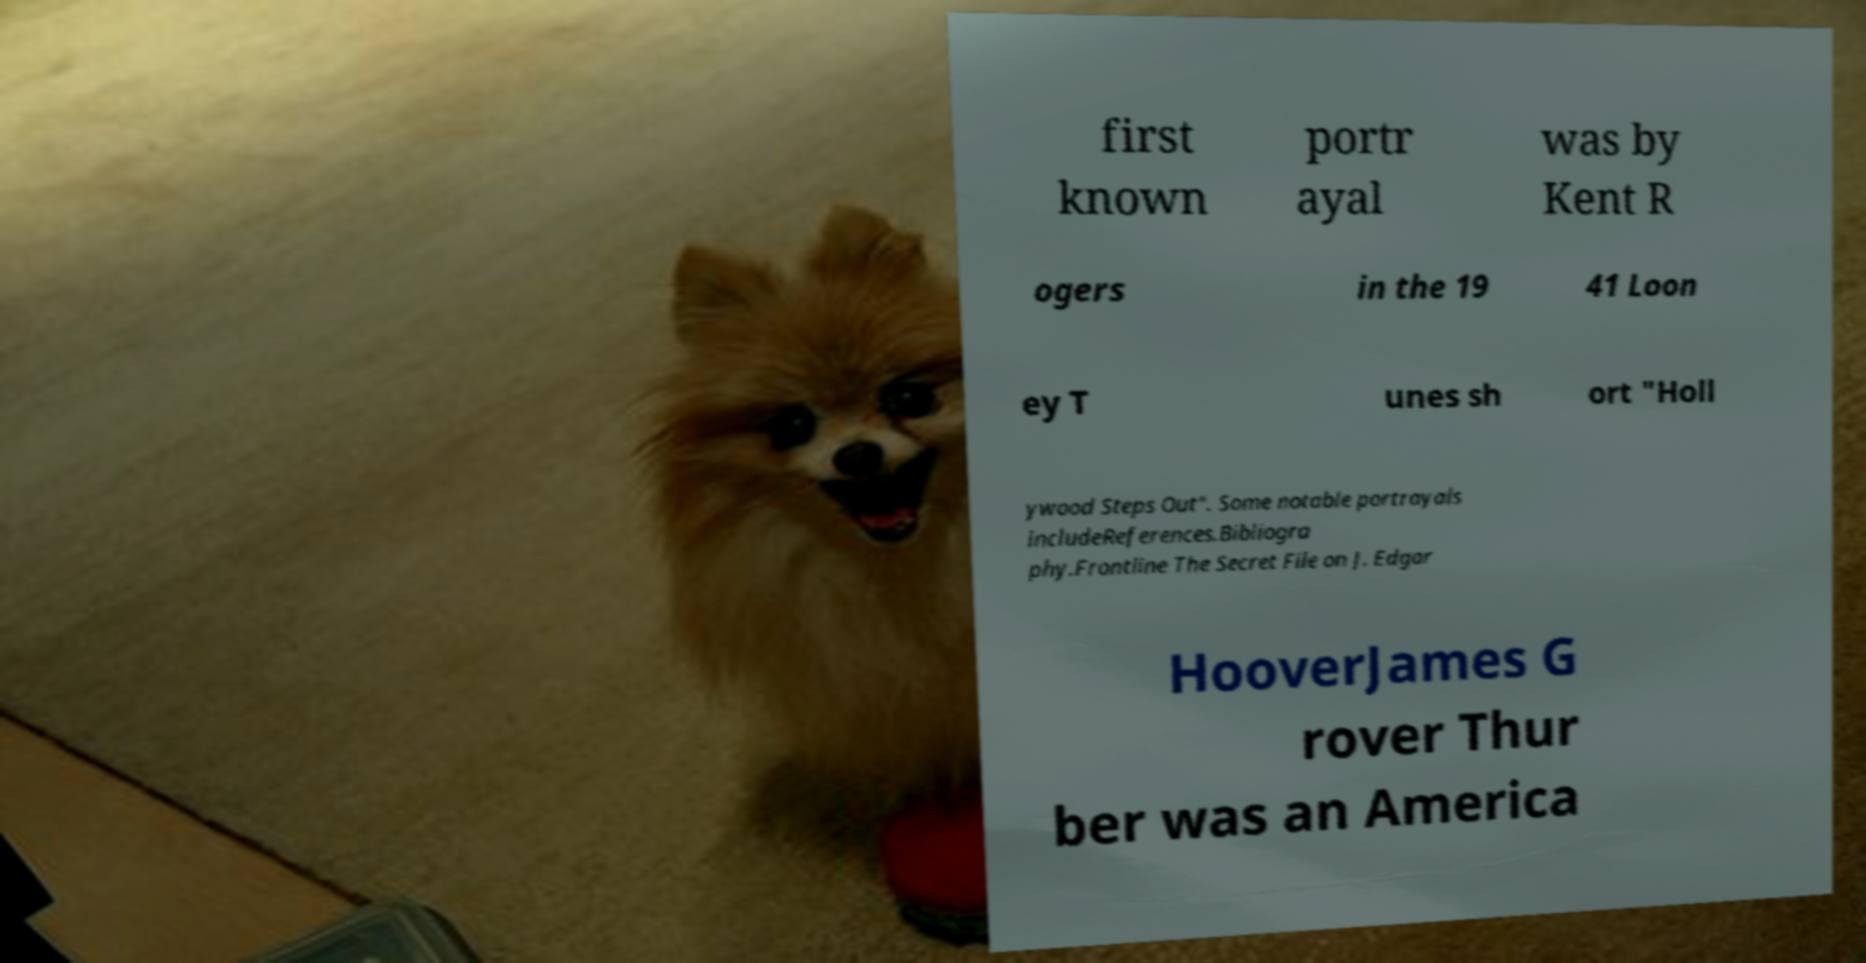There's text embedded in this image that I need extracted. Can you transcribe it verbatim? first known portr ayal was by Kent R ogers in the 19 41 Loon ey T unes sh ort "Holl ywood Steps Out". Some notable portrayals includeReferences.Bibliogra phy.Frontline The Secret File on J. Edgar HooverJames G rover Thur ber was an America 